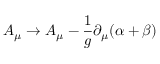<formula> <loc_0><loc_0><loc_500><loc_500>A _ { \mu } \to A _ { \mu } - \frac { 1 } { g } \partial _ { \mu } ( \alpha + \beta )</formula> 